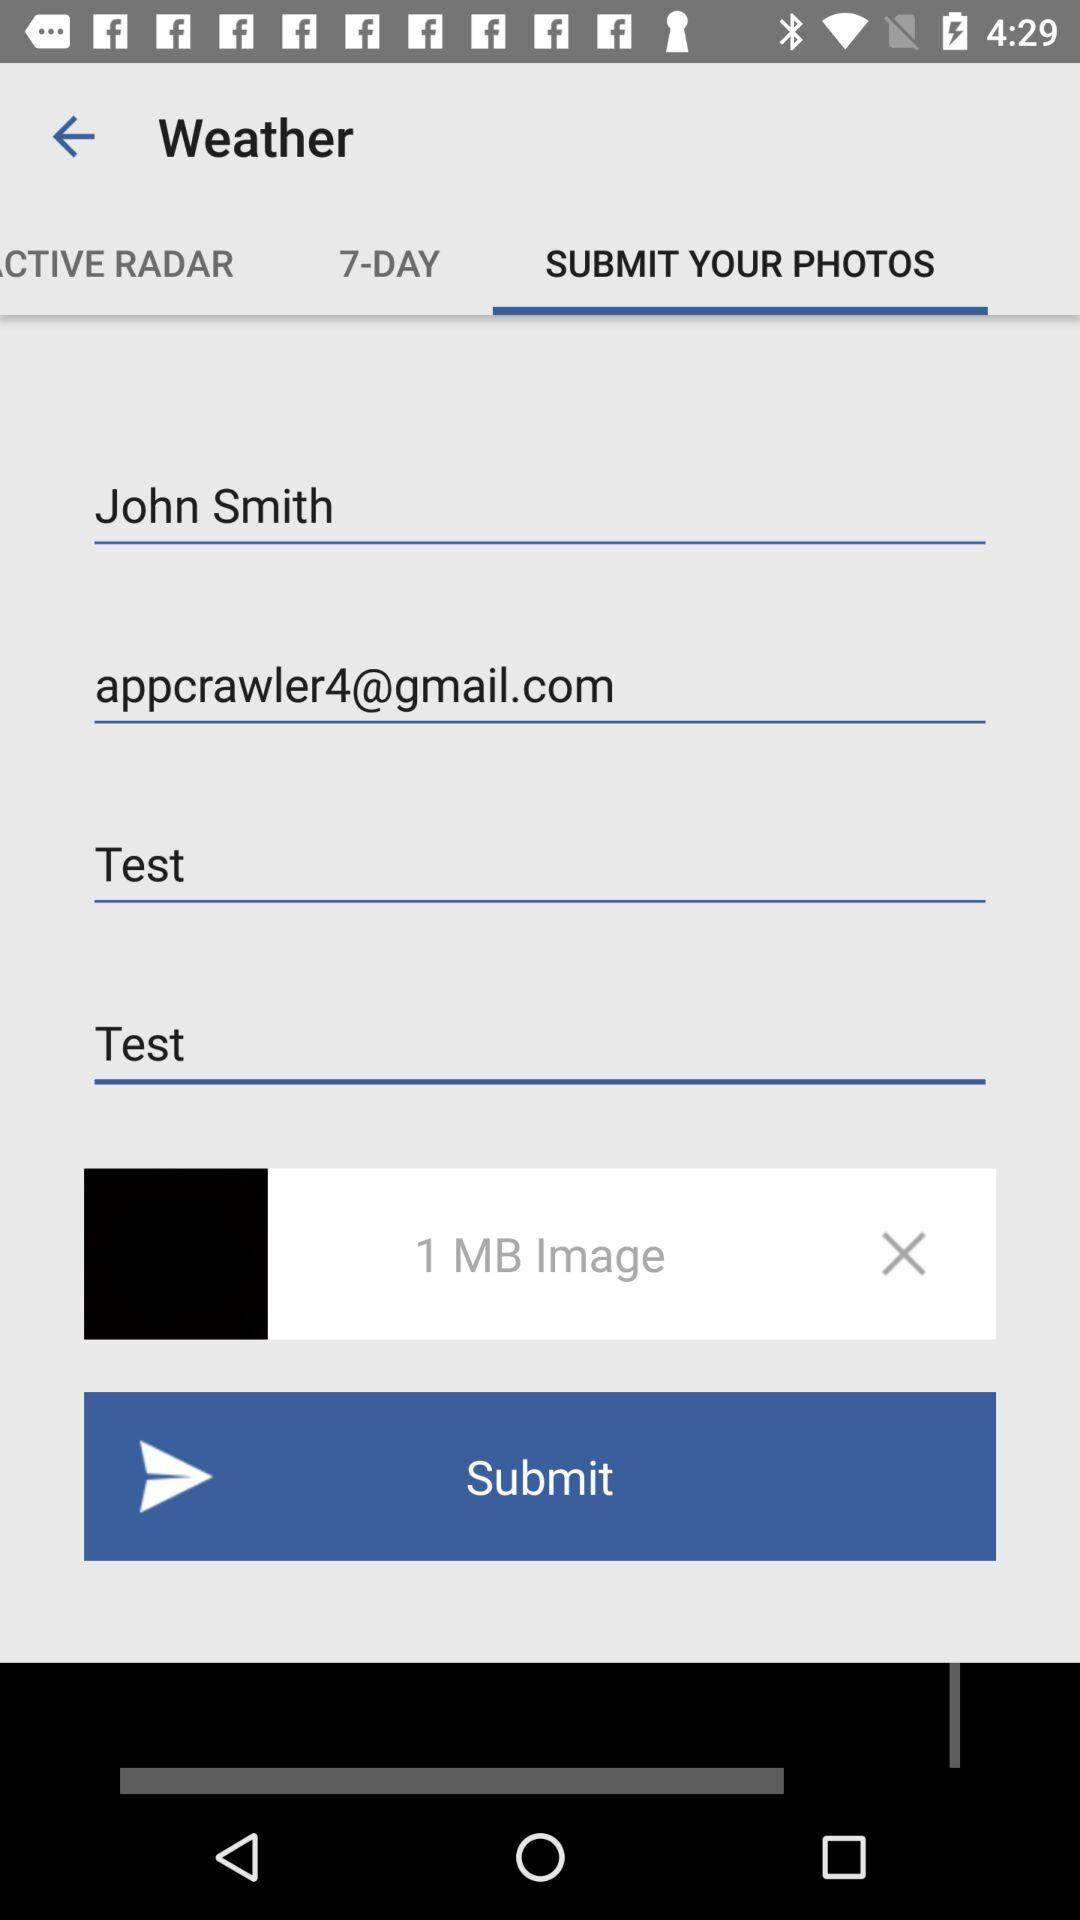Which tab is selected? The selected tab is "SUMBIT YOUR PHOTOS". 